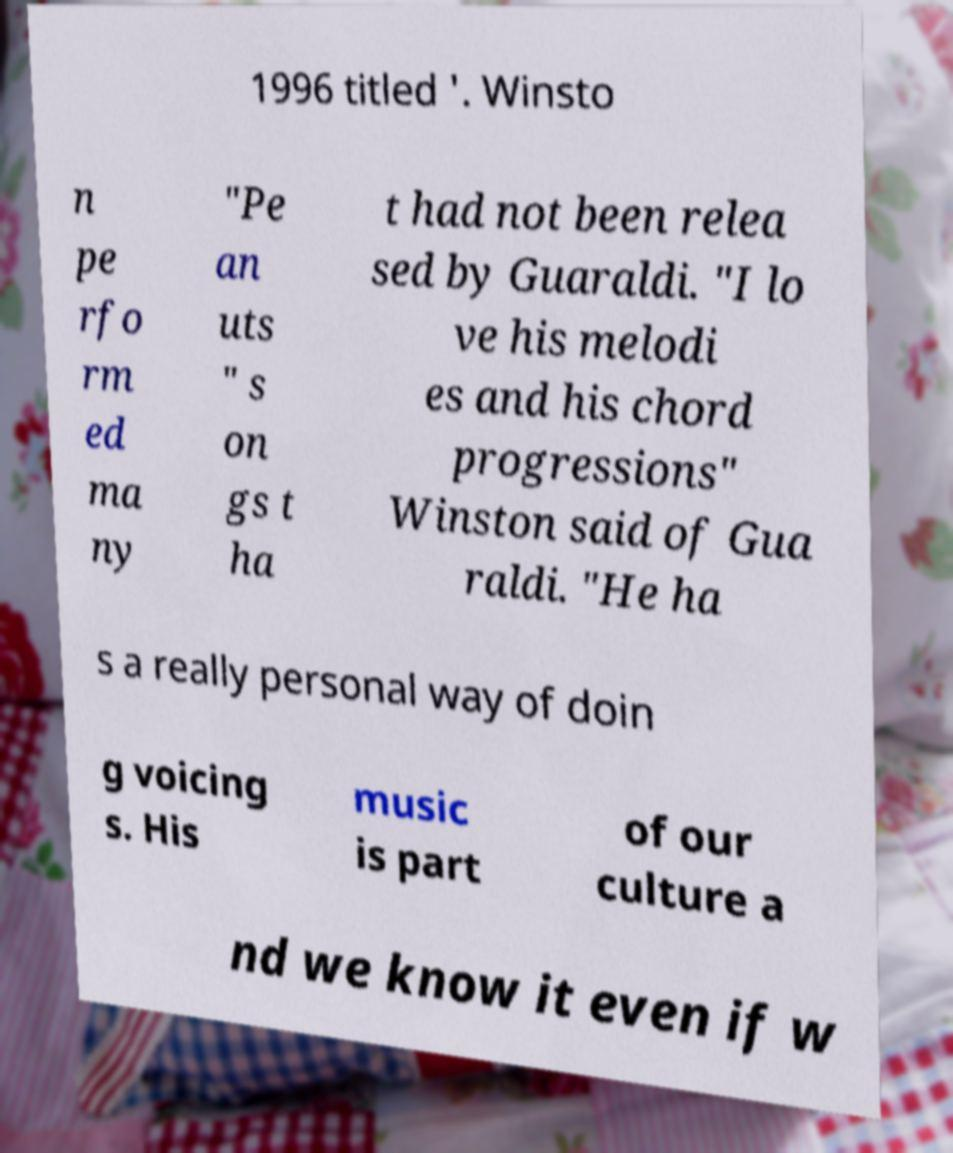Please read and relay the text visible in this image. What does it say? 1996 titled '. Winsto n pe rfo rm ed ma ny "Pe an uts " s on gs t ha t had not been relea sed by Guaraldi. "I lo ve his melodi es and his chord progressions" Winston said of Gua raldi. "He ha s a really personal way of doin g voicing s. His music is part of our culture a nd we know it even if w 